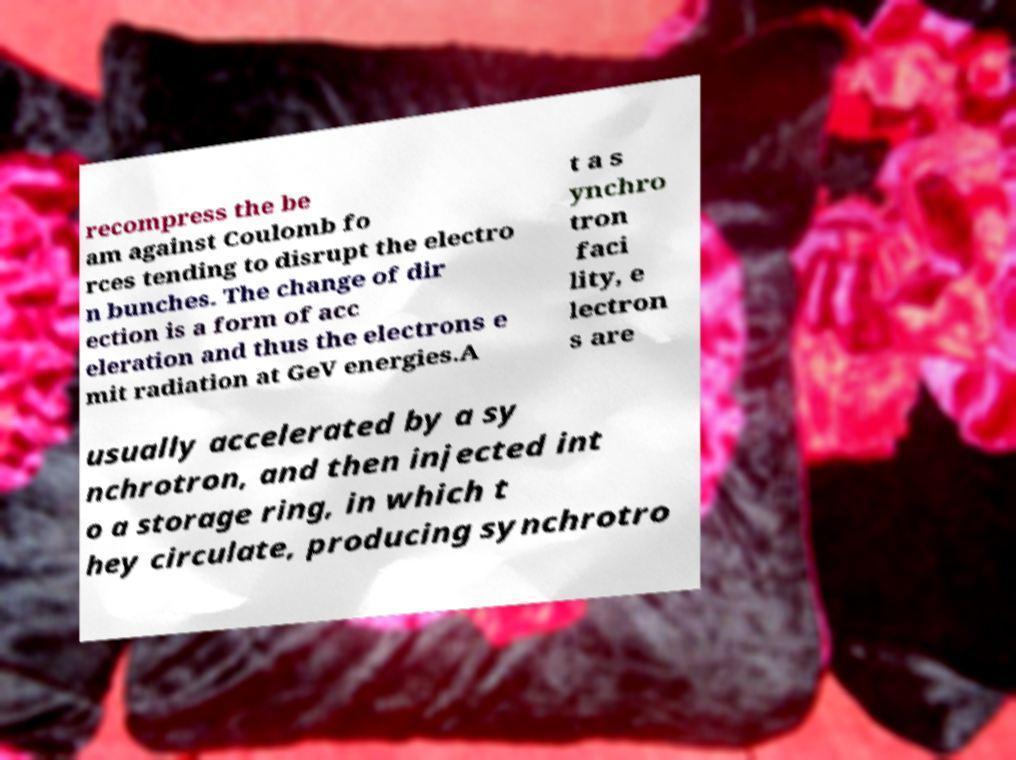For documentation purposes, I need the text within this image transcribed. Could you provide that? recompress the be am against Coulomb fo rces tending to disrupt the electro n bunches. The change of dir ection is a form of acc eleration and thus the electrons e mit radiation at GeV energies.A t a s ynchro tron faci lity, e lectron s are usually accelerated by a sy nchrotron, and then injected int o a storage ring, in which t hey circulate, producing synchrotro 